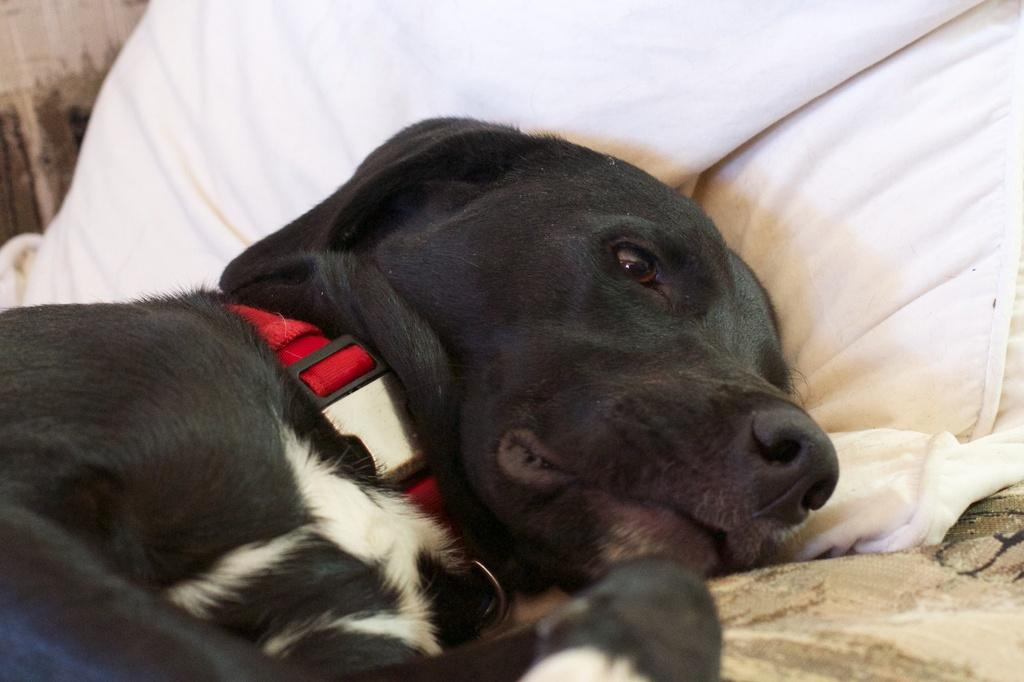What type of animal is in the foreground of the image? There is a black dog in the foreground of the image. What is the dog doing in the image? The dog is lying on a bed. What color is the pillow on the bed? The pillow on the bed is white. What is the dog wearing around its neck? The dog has a red belt around its neck. How many trucks are parked next to the dog in the image? There are no trucks present in the image; it features a black dog lying on a bed with a white pillow and a red belt around its neck. 